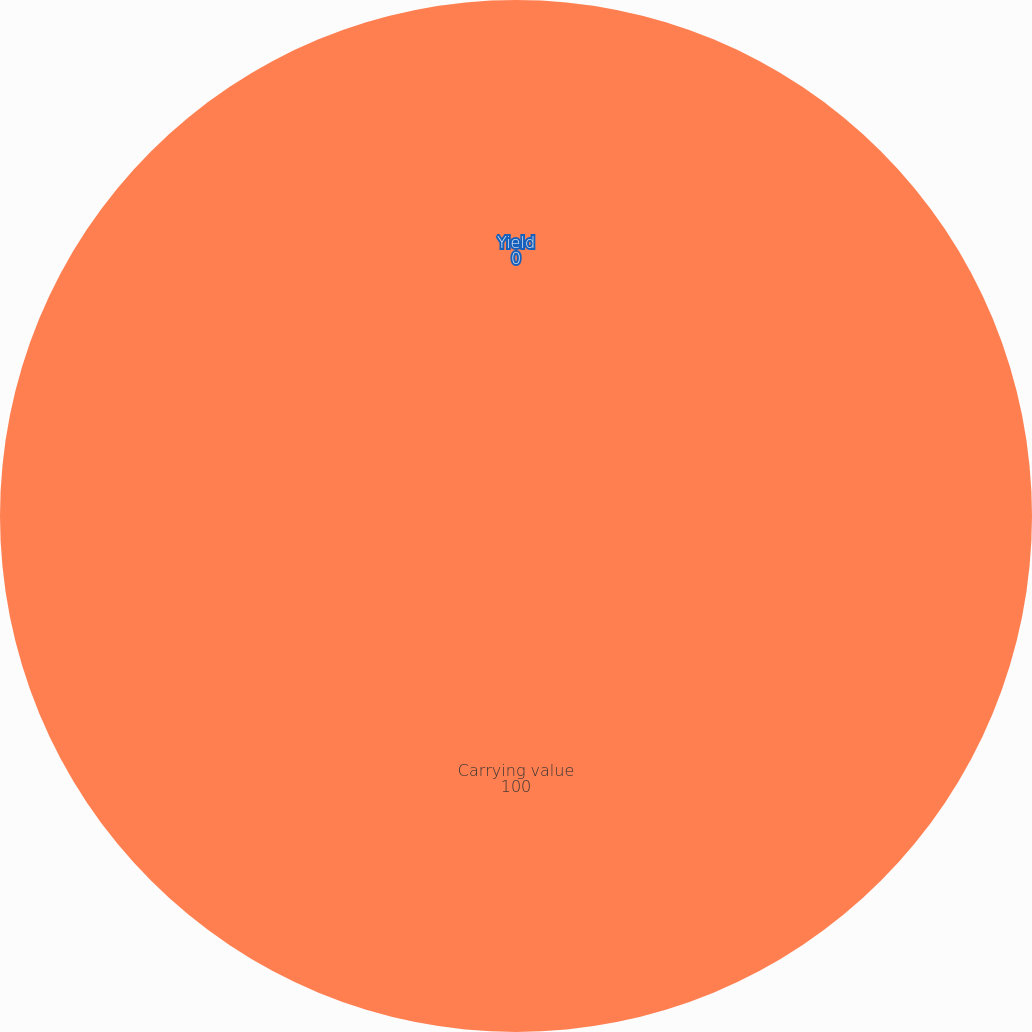Convert chart to OTSL. <chart><loc_0><loc_0><loc_500><loc_500><pie_chart><fcel>Carrying value<fcel>Yield<nl><fcel>100.0%<fcel>0.0%<nl></chart> 